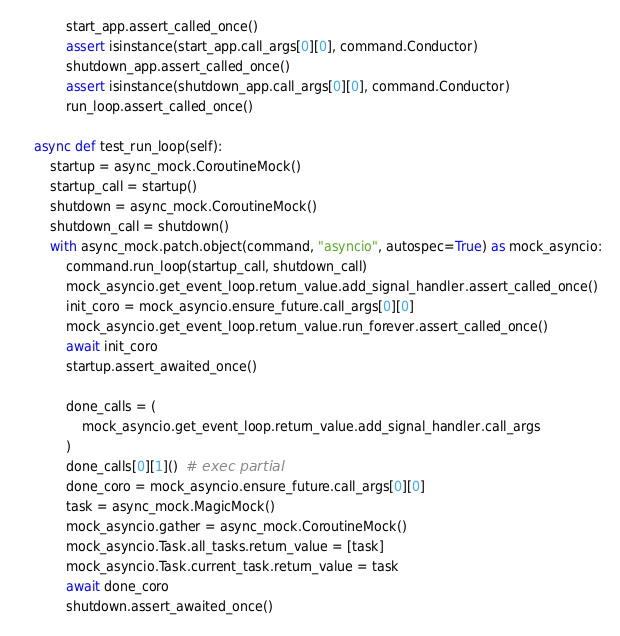Convert code to text. <code><loc_0><loc_0><loc_500><loc_500><_Python_>            start_app.assert_called_once()
            assert isinstance(start_app.call_args[0][0], command.Conductor)
            shutdown_app.assert_called_once()
            assert isinstance(shutdown_app.call_args[0][0], command.Conductor)
            run_loop.assert_called_once()

    async def test_run_loop(self):
        startup = async_mock.CoroutineMock()
        startup_call = startup()
        shutdown = async_mock.CoroutineMock()
        shutdown_call = shutdown()
        with async_mock.patch.object(command, "asyncio", autospec=True) as mock_asyncio:
            command.run_loop(startup_call, shutdown_call)
            mock_asyncio.get_event_loop.return_value.add_signal_handler.assert_called_once()
            init_coro = mock_asyncio.ensure_future.call_args[0][0]
            mock_asyncio.get_event_loop.return_value.run_forever.assert_called_once()
            await init_coro
            startup.assert_awaited_once()

            done_calls = (
                mock_asyncio.get_event_loop.return_value.add_signal_handler.call_args
            )
            done_calls[0][1]()  # exec partial
            done_coro = mock_asyncio.ensure_future.call_args[0][0]
            task = async_mock.MagicMock()
            mock_asyncio.gather = async_mock.CoroutineMock()
            mock_asyncio.Task.all_tasks.return_value = [task]
            mock_asyncio.Task.current_task.return_value = task
            await done_coro
            shutdown.assert_awaited_once()
</code> 